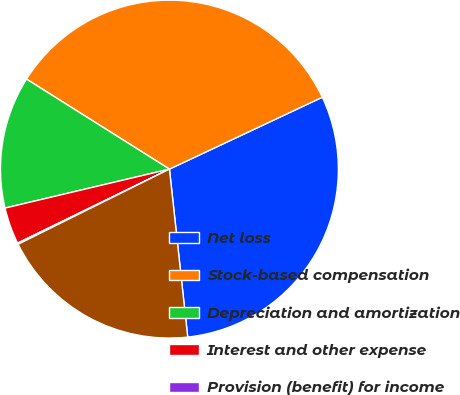Convert chart. <chart><loc_0><loc_0><loc_500><loc_500><pie_chart><fcel>Net loss<fcel>Stock-based compensation<fcel>Depreciation and amortization<fcel>Interest and other expense<fcel>Provision (benefit) for income<fcel>Adjusted EBITDA<nl><fcel>30.27%<fcel>34.06%<fcel>12.65%<fcel>3.51%<fcel>0.12%<fcel>19.39%<nl></chart> 